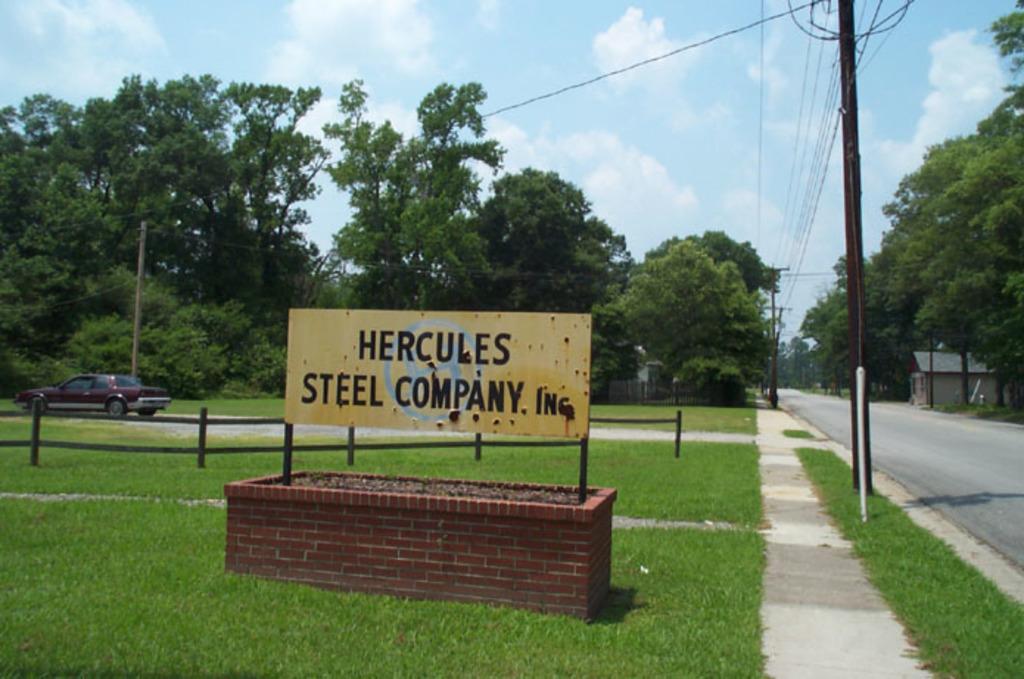Please provide a concise description of this image. In this image I can see a road on the right side and both side of it I can see number of trees, grass, fed poles and few wires. In the front I can see a yellow colour board and on it I can see something is written. I can also see a car on the left side of this image and in the background I can see clouds and the sky. 